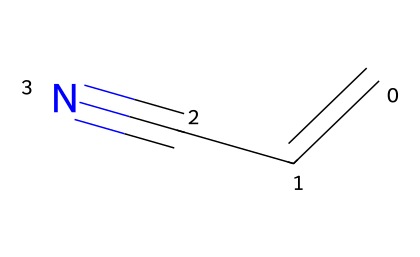What is the name of this chemical? The SMILES representation "C=CC#N" corresponds to a compound where "C" indicates carbon atoms, "=" indicates a double bond, and "#N" indicates a nitrile group with a triple bond to nitrogen. This structure identifies the compound as acrylonitrile.
Answer: acrylonitrile How many carbon atoms are in acrylonitrile? By analyzing the SMILES, there are three "C" labels, indicating three carbon atoms present in the structure of acrylonitrile.
Answer: 3 What type of functional group is present in acrylonitrile? The "#N" in the SMILES indicates that there is a triple bond between carbon and nitrogen, which signifies the presence of a nitrile functional group.
Answer: nitrile How many bonds connect the carbon atoms in acrylonitrile? In the chain, the first and second carbons are connected by a double bond (indicated by "="), and the second and third carbons are connected by a single bond. Therefore, there are a total of two bonds connecting the carbon atoms.
Answer: 2 What is the maximum number of hydrogen atoms possible for acrylonitrile? The structure shows two hydrogen atoms on the first carbon, one on the second carbon, and none on the third due to its connection to the nitrogen. Using the general formula for alkenes and correcting for the nitrile, the maximum is determined to be four hydrogen atoms.
Answer: 4 Is acrylonitrile aromatic? Acrylonitrile does not contain a benzene ring or any cyclic structure that fits the definition of aromatic compounds, as implied by its linear chain of atoms.
Answer: no 